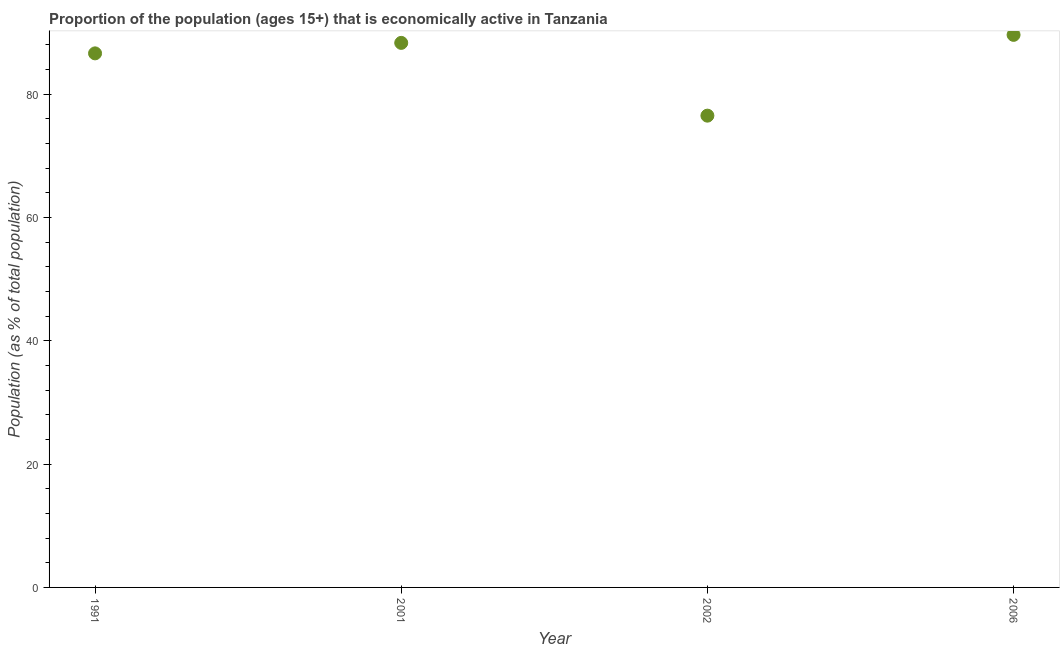What is the percentage of economically active population in 2006?
Your answer should be compact. 89.6. Across all years, what is the maximum percentage of economically active population?
Your response must be concise. 89.6. Across all years, what is the minimum percentage of economically active population?
Offer a terse response. 76.5. In which year was the percentage of economically active population maximum?
Keep it short and to the point. 2006. In which year was the percentage of economically active population minimum?
Offer a terse response. 2002. What is the sum of the percentage of economically active population?
Your answer should be very brief. 341. What is the difference between the percentage of economically active population in 2002 and 2006?
Offer a very short reply. -13.1. What is the average percentage of economically active population per year?
Provide a succinct answer. 85.25. What is the median percentage of economically active population?
Your answer should be very brief. 87.45. In how many years, is the percentage of economically active population greater than 56 %?
Keep it short and to the point. 4. What is the ratio of the percentage of economically active population in 2002 to that in 2006?
Your answer should be very brief. 0.85. Is the difference between the percentage of economically active population in 1991 and 2001 greater than the difference between any two years?
Provide a succinct answer. No. What is the difference between the highest and the second highest percentage of economically active population?
Your answer should be very brief. 1.3. What is the difference between the highest and the lowest percentage of economically active population?
Offer a terse response. 13.1. In how many years, is the percentage of economically active population greater than the average percentage of economically active population taken over all years?
Ensure brevity in your answer.  3. How many dotlines are there?
Your answer should be very brief. 1. How many years are there in the graph?
Make the answer very short. 4. What is the difference between two consecutive major ticks on the Y-axis?
Your answer should be compact. 20. Does the graph contain grids?
Provide a succinct answer. No. What is the title of the graph?
Your response must be concise. Proportion of the population (ages 15+) that is economically active in Tanzania. What is the label or title of the X-axis?
Provide a succinct answer. Year. What is the label or title of the Y-axis?
Make the answer very short. Population (as % of total population). What is the Population (as % of total population) in 1991?
Make the answer very short. 86.6. What is the Population (as % of total population) in 2001?
Provide a succinct answer. 88.3. What is the Population (as % of total population) in 2002?
Make the answer very short. 76.5. What is the Population (as % of total population) in 2006?
Offer a very short reply. 89.6. What is the difference between the Population (as % of total population) in 1991 and 2006?
Offer a terse response. -3. What is the difference between the Population (as % of total population) in 2001 and 2002?
Offer a terse response. 11.8. What is the difference between the Population (as % of total population) in 2002 and 2006?
Your answer should be very brief. -13.1. What is the ratio of the Population (as % of total population) in 1991 to that in 2001?
Ensure brevity in your answer.  0.98. What is the ratio of the Population (as % of total population) in 1991 to that in 2002?
Offer a terse response. 1.13. What is the ratio of the Population (as % of total population) in 1991 to that in 2006?
Your response must be concise. 0.97. What is the ratio of the Population (as % of total population) in 2001 to that in 2002?
Keep it short and to the point. 1.15. What is the ratio of the Population (as % of total population) in 2001 to that in 2006?
Provide a short and direct response. 0.98. What is the ratio of the Population (as % of total population) in 2002 to that in 2006?
Your answer should be compact. 0.85. 